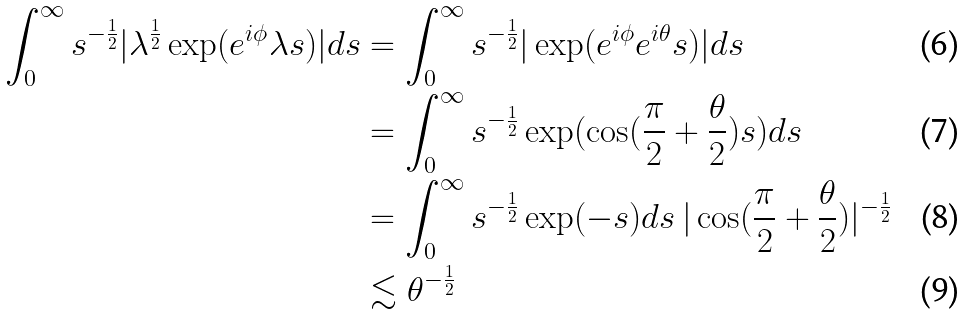Convert formula to latex. <formula><loc_0><loc_0><loc_500><loc_500>\int _ { 0 } ^ { \infty } s ^ { - \frac { 1 } { 2 } } | \lambda ^ { \frac { 1 } { 2 } } \exp ( e ^ { i \phi } \lambda s ) | d s & = \int _ { 0 } ^ { \infty } s ^ { - \frac { 1 } { 2 } } | \exp ( e ^ { i \phi } e ^ { i \theta } s ) | d s \\ & = \int _ { 0 } ^ { \infty } s ^ { - \frac { 1 } { 2 } } \exp ( \cos ( \frac { \pi } { 2 } + \frac { \theta } { 2 } ) s ) d s \\ & = \int _ { 0 } ^ { \infty } s ^ { - \frac { 1 } { 2 } } \exp ( - s ) d s \, | \cos ( \frac { \pi } { 2 } + \frac { \theta } { 2 } ) | ^ { - \frac { 1 } { 2 } } \\ & \lesssim \theta ^ { - \frac { 1 } { 2 } }</formula> 